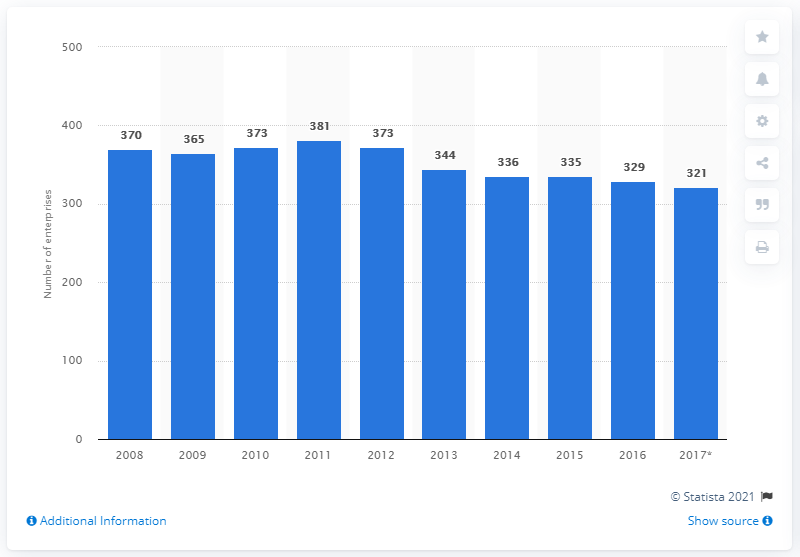Mention a couple of crucial points in this snapshot. In 2016, there were 329 enterprises in Sweden that manufactured glass and glass products. 